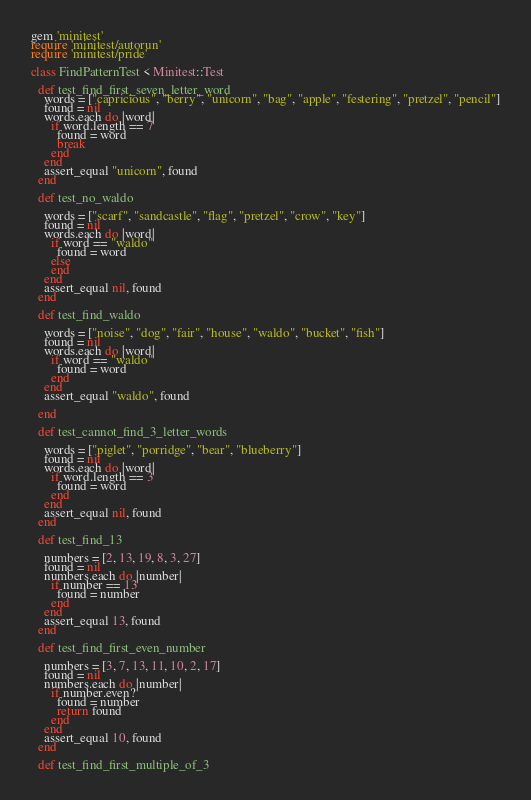Convert code to text. <code><loc_0><loc_0><loc_500><loc_500><_Ruby_>gem 'minitest'
require 'minitest/autorun'
require 'minitest/pride'

class FindPatternTest < Minitest::Test

  def test_find_first_seven_letter_word
    words = ["capricious", "berry", "unicorn", "bag", "apple", "festering", "pretzel", "pencil"]
    found = nil
    words.each do |word|
      if word.length == 7
        found = word
        break
      end
    end
    assert_equal "unicorn", found
  end

  def test_no_waldo

    words = ["scarf", "sandcastle", "flag", "pretzel", "crow", "key"]
    found = nil
    words.each do |word|
      if word == "waldo"
        found = word
      else
      end
    end
    assert_equal nil, found
  end

  def test_find_waldo

    words = ["noise", "dog", "fair", "house", "waldo", "bucket", "fish"]
    found = nil
    words.each do |word|
      if word == "waldo"
        found = word
      end
    end
    assert_equal "waldo", found

  end

  def test_cannot_find_3_letter_words

    words = ["piglet", "porridge", "bear", "blueberry"]
    found = nil
    words.each do |word|
      if word.length == 3
        found = word
      end
    end
    assert_equal nil, found
  end

  def test_find_13

    numbers = [2, 13, 19, 8, 3, 27]
    found = nil
    numbers.each do |number|
      if number == 13
        found = number
      end
    end
    assert_equal 13, found
  end

  def test_find_first_even_number

    numbers = [3, 7, 13, 11, 10, 2, 17]
    found = nil
    numbers.each do |number|
      if number.even?
        found = number
        return found
      end
    end
    assert_equal 10, found
  end

  def test_find_first_multiple_of_3
</code> 